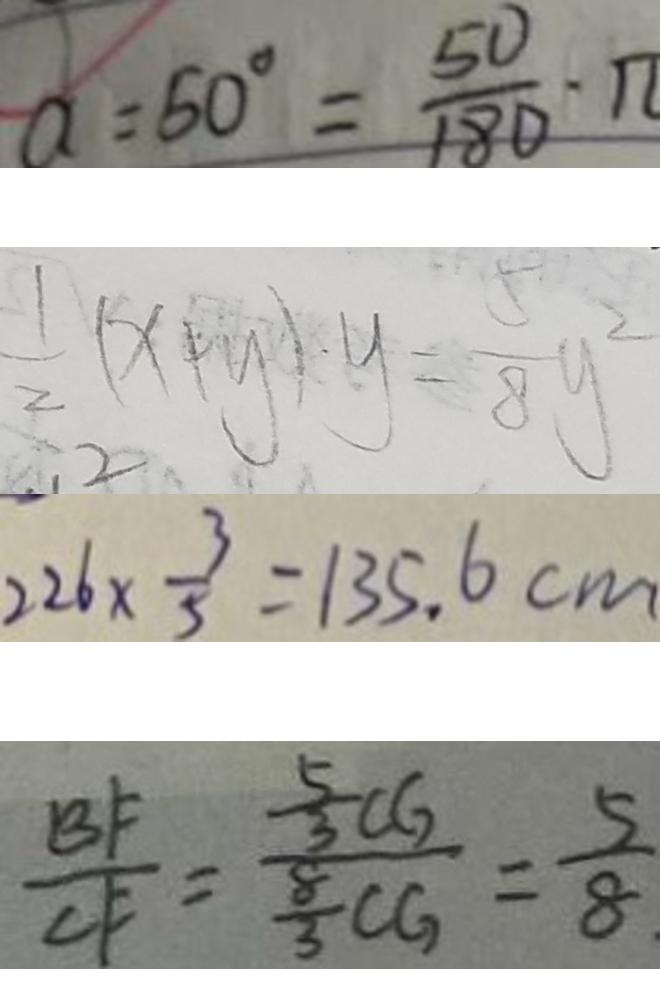<formula> <loc_0><loc_0><loc_500><loc_500>a = 6 0 ^ { \circ } = \frac { 5 0 } { 1 8 0 } \cdot \pi 
 \frac { 1 } { 2 } ( x + y ) \cdot y = \frac { 5 } { 8 } y ^ { 2 } 
 2 2 6 \times \frac { 3 } { 5 } = 1 3 5 . 6 c m 
 \frac { B F } { C F } = \frac { \frac { 5 } { 3 } C G } { \frac { 8 } { 3 } C G } = \frac { 5 } { 8 }</formula> 